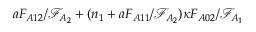<formula> <loc_0><loc_0><loc_500><loc_500>a F _ { A 1 2 } / \mathcal { F } _ { A _ { 2 } } + ( n _ { 1 } + a F _ { A 1 1 } / \mathcal { F } _ { A _ { 2 } } ) \kappa F _ { A 0 2 } / \mathcal { F } _ { A _ { 1 } }</formula> 